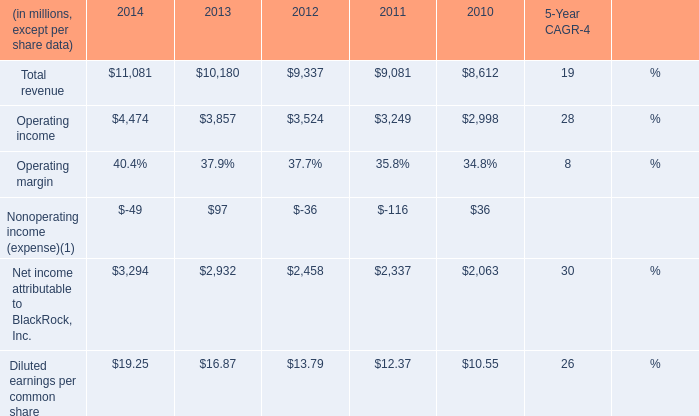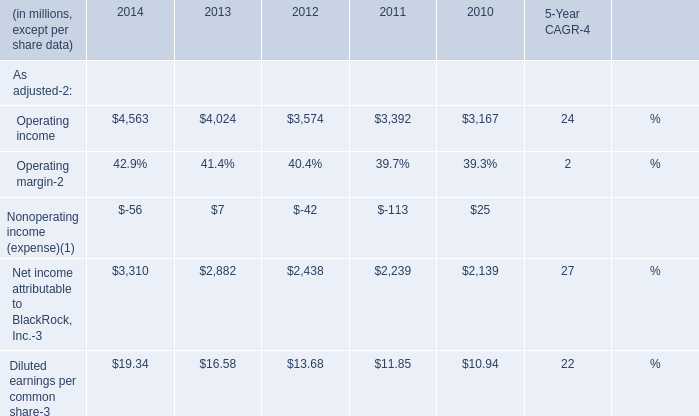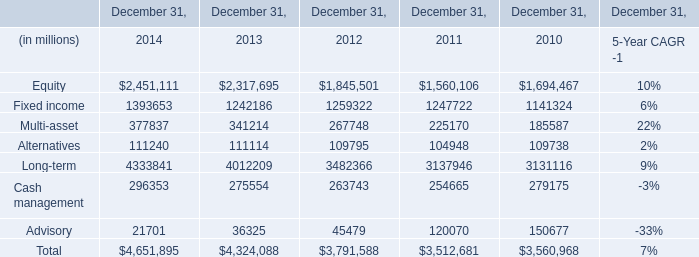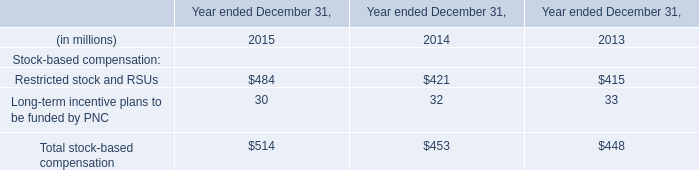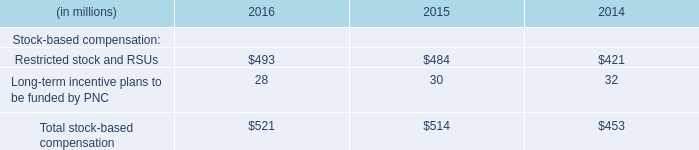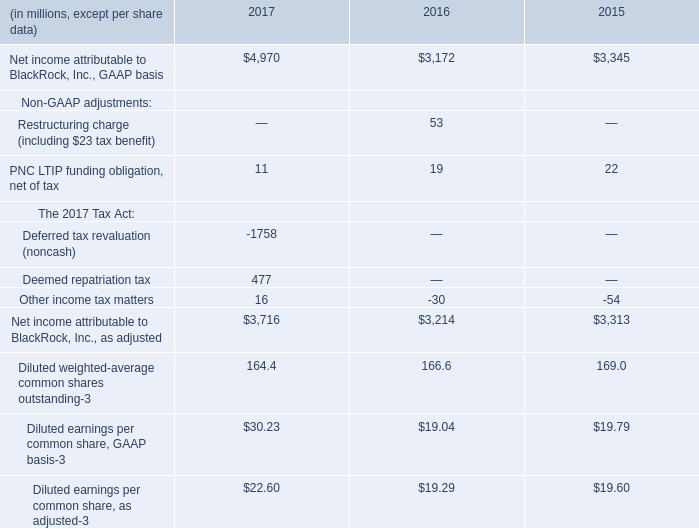What's the sum of Cash management of December 31, 2014, and Operating income of 2012 ? 
Computations: (296353.0 + 3524.0)
Answer: 299877.0. 